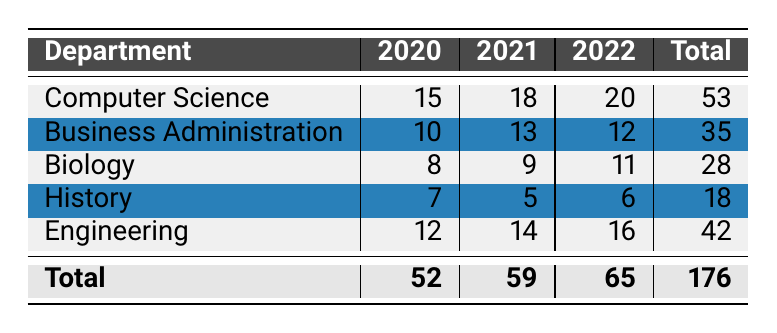What is the total number of publications in 2021? To find the total number of publications in 2021, sum the values for each department in that year: Computer Science (18) + Business Administration (13) + Biology (9) + History (5) + Engineering (14) = 59
Answer: 59 Which department had the highest number of publications in 2022? Comparing the publication numbers for each department in 2022: Computer Science (20), Business Administration (12), Biology (11), History (6), Engineering (16). The highest is Computer Science with 20 publications.
Answer: Computer Science What is the average number of publications for the Engineering department over the three years? The total number of publications for the Engineering department over the years is 12 + 14 + 16 = 42. To find the average, divide by the number of years (3): 42 / 3 = 14.
Answer: 14 Did the Biology department produce more publications in 2022 than in 2020? For Biology, the publications were 11 in 2022 and 8 in 2020. Since 11 is greater than 8, it can be concluded that they produced more publications in 2022 than in 2020.
Answer: Yes How many total publications were produced by the Business Administration department across all years? The total for Business Administration is obtained by adding the publications from all years: 10 (2020) + 13 (2021) + 12 (2022) = 35.
Answer: 35 Which year had the lowest total number of publications across all departments? Adding the total publications by year, we find: 52 (2020) + 59 (2021) + 65 (2022). The year with the lowest total is 2020 with 52 publications.
Answer: 2020 How many more publications did Computer Science have in 2022 compared to Business Administration in the same year? In 2022, Computer Science had 20 publications and Business Administration had 12. The difference is 20 - 12 = 8, indicating that Computer Science had 8 more publications.
Answer: 8 Was the total of 2020 publications higher than the total of 2021 publications? The total publications for 2020 is 52 and for 2021 it is 59. Since 52 is less than 59, 2020 did not have higher publications.
Answer: No 